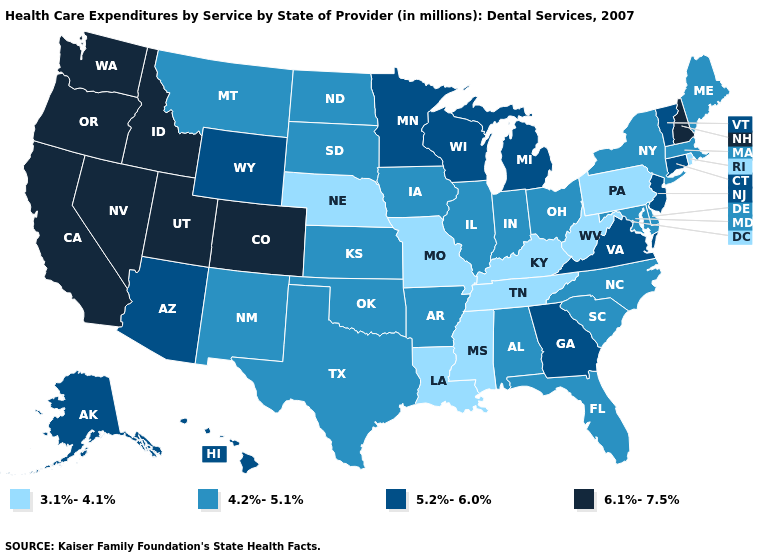Does Rhode Island have the lowest value in the Northeast?
Answer briefly. Yes. What is the value of Mississippi?
Be succinct. 3.1%-4.1%. Which states hav the highest value in the West?
Quick response, please. California, Colorado, Idaho, Nevada, Oregon, Utah, Washington. Which states have the lowest value in the USA?
Keep it brief. Kentucky, Louisiana, Mississippi, Missouri, Nebraska, Pennsylvania, Rhode Island, Tennessee, West Virginia. Name the states that have a value in the range 3.1%-4.1%?
Short answer required. Kentucky, Louisiana, Mississippi, Missouri, Nebraska, Pennsylvania, Rhode Island, Tennessee, West Virginia. What is the value of Rhode Island?
Concise answer only. 3.1%-4.1%. What is the value of Oregon?
Write a very short answer. 6.1%-7.5%. Name the states that have a value in the range 4.2%-5.1%?
Answer briefly. Alabama, Arkansas, Delaware, Florida, Illinois, Indiana, Iowa, Kansas, Maine, Maryland, Massachusetts, Montana, New Mexico, New York, North Carolina, North Dakota, Ohio, Oklahoma, South Carolina, South Dakota, Texas. Does Montana have the lowest value in the West?
Write a very short answer. Yes. Is the legend a continuous bar?
Concise answer only. No. What is the value of Delaware?
Give a very brief answer. 4.2%-5.1%. Name the states that have a value in the range 4.2%-5.1%?
Be succinct. Alabama, Arkansas, Delaware, Florida, Illinois, Indiana, Iowa, Kansas, Maine, Maryland, Massachusetts, Montana, New Mexico, New York, North Carolina, North Dakota, Ohio, Oklahoma, South Carolina, South Dakota, Texas. Among the states that border Kansas , which have the lowest value?
Write a very short answer. Missouri, Nebraska. Name the states that have a value in the range 4.2%-5.1%?
Keep it brief. Alabama, Arkansas, Delaware, Florida, Illinois, Indiana, Iowa, Kansas, Maine, Maryland, Massachusetts, Montana, New Mexico, New York, North Carolina, North Dakota, Ohio, Oklahoma, South Carolina, South Dakota, Texas. 